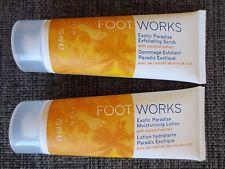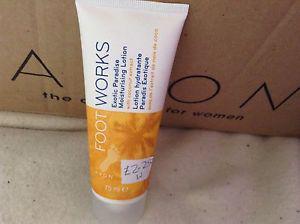The first image is the image on the left, the second image is the image on the right. Examine the images to the left and right. Is the description "The products are of the FootWorks brand." accurate? Answer yes or no. Yes. The first image is the image on the left, the second image is the image on the right. Examine the images to the left and right. Is the description "An image shows a product with orange-and-white tube-type container standing upright on its cap." accurate? Answer yes or no. Yes. 